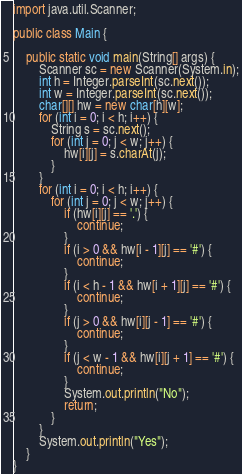<code> <loc_0><loc_0><loc_500><loc_500><_Java_>import java.util.Scanner;

public class Main {

    public static void main(String[] args) {
        Scanner sc = new Scanner(System.in);
        int h = Integer.parseInt(sc.next());
        int w = Integer.parseInt(sc.next());
        char[][] hw = new char[h][w];
        for (int i = 0; i < h; i++) {
            String s = sc.next();
            for (int j = 0; j < w; j++) {
                hw[i][j] = s.charAt(j);
            }
        }
        for (int i = 0; i < h; i++) {
            for (int j = 0; j < w; j++) {
                if (hw[i][j] == '.') {
                    continue;
                }
                if (i > 0 && hw[i - 1][j] == '#') {
                    continue;
                }
                if (i < h - 1 && hw[i + 1][j] == '#') {
                    continue;
                }
                if (j > 0 && hw[i][j - 1] == '#') {
                    continue;
                }
                if (j < w - 1 && hw[i][j + 1] == '#') {
                    continue;
                }
                System.out.println("No");
                return;
            }
        }
        System.out.println("Yes");
    }
}</code> 